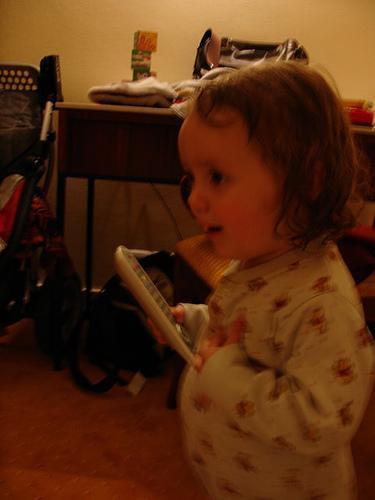How many remote controls are there?
Give a very brief answer. 1. 